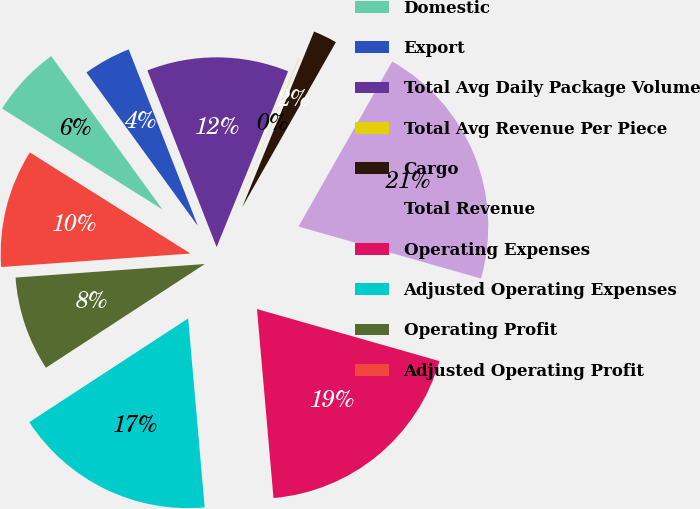<chart> <loc_0><loc_0><loc_500><loc_500><pie_chart><fcel>Domestic<fcel>Export<fcel>Total Avg Daily Package Volume<fcel>Total Avg Revenue Per Piece<fcel>Cargo<fcel>Total Revenue<fcel>Operating Expenses<fcel>Adjusted Operating Expenses<fcel>Operating Profit<fcel>Adjusted Operating Profit<nl><fcel>6.06%<fcel>4.05%<fcel>12.09%<fcel>0.03%<fcel>2.04%<fcel>21.2%<fcel>19.19%<fcel>17.18%<fcel>8.07%<fcel>10.08%<nl></chart> 